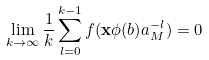<formula> <loc_0><loc_0><loc_500><loc_500>\lim _ { k \to \infty } \frac { 1 } { k } \sum _ { l = 0 } ^ { k - 1 } f ( \mathbf x \phi ( b ) a ^ { - l } _ { M } ) = 0</formula> 